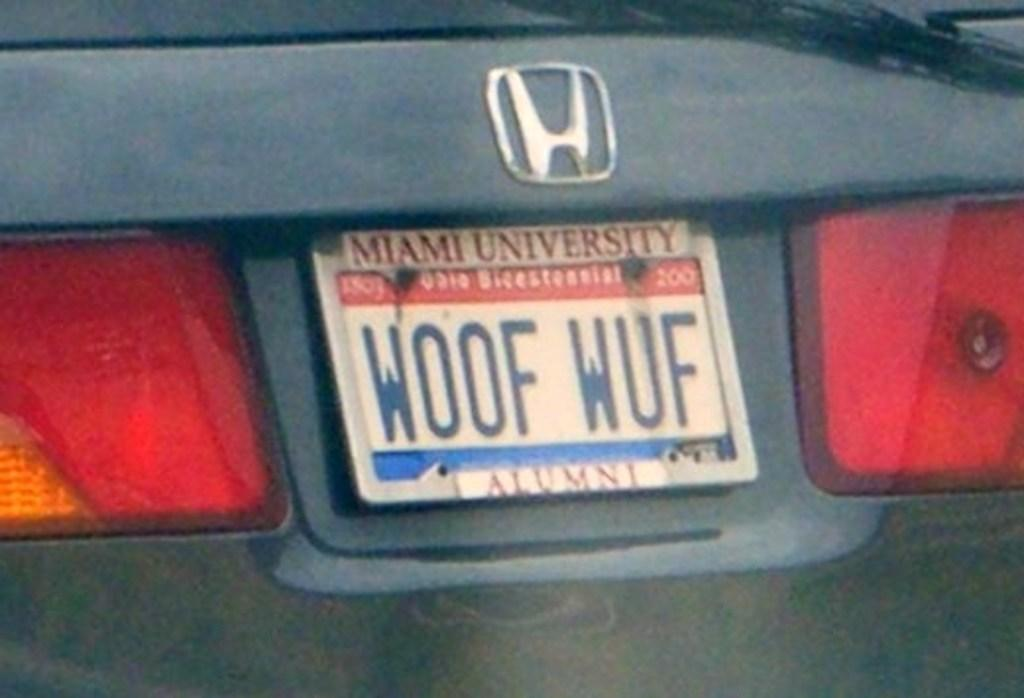Provide a one-sentence caption for the provided image. A car made by Honda has a license plate that says Woof Wuf. 